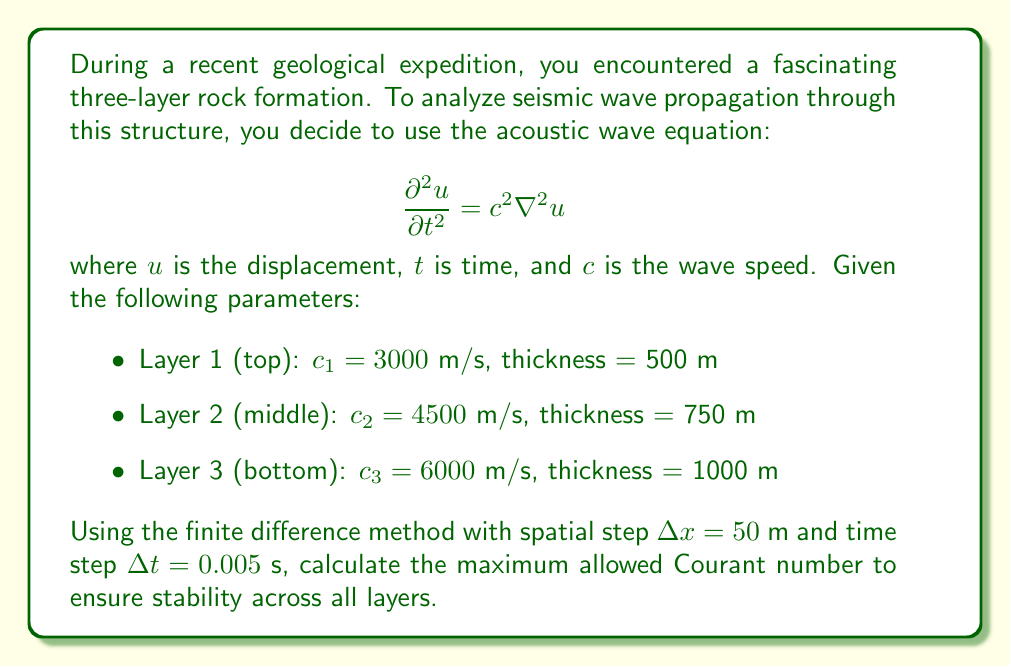Provide a solution to this math problem. To solve this problem, we'll follow these steps:

1) Recall the Courant-Friedrichs-Lewy (CFL) condition for the 1D acoustic wave equation:

   $$\text{Courant number} = \frac{c \Delta t}{\Delta x} \leq 1$$

2) Calculate the Courant number for each layer:

   Layer 1: $\frac{c_1 \Delta t}{\Delta x} = \frac{3000 \cdot 0.005}{50} = 0.3$
   
   Layer 2: $\frac{c_2 \Delta t}{\Delta x} = \frac{4500 \cdot 0.005}{50} = 0.45$
   
   Layer 3: $\frac{c_3 \Delta t}{\Delta x} = \frac{6000 \cdot 0.005}{50} = 0.6$

3) The maximum Courant number occurs in the layer with the highest wave speed, which is Layer 3.

4) Therefore, the maximum Courant number across all layers is 0.6.

5) This value is less than 1, so the stability condition is satisfied for all layers.
Answer: 0.6 